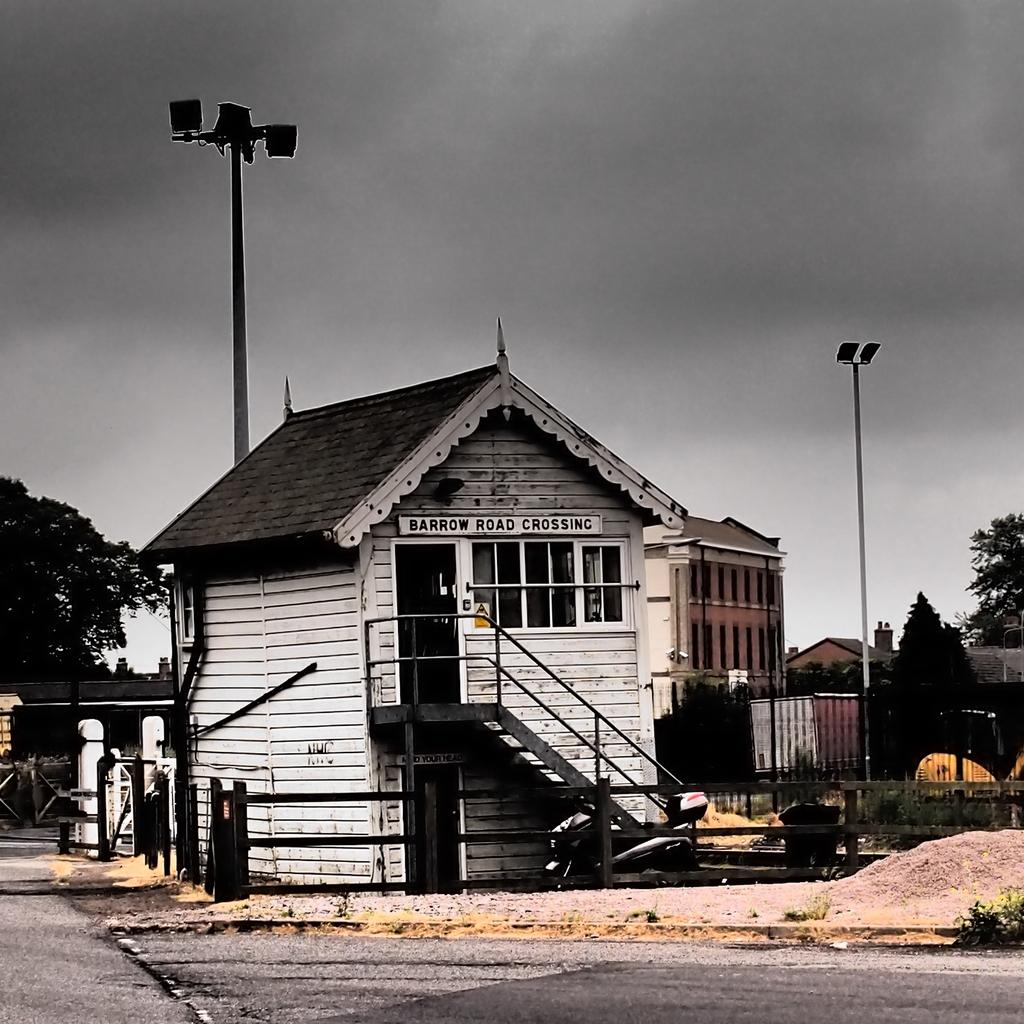What type of house is in the image? There is a wooden house in the image. What feature can be seen on the wooden house? The wooden house has glass windows. Where is the wooden house located in relation to the road? The wooden house is near a road. What can be seen in the background of the image? There are lights attached to poles, buildings, trees, and clouds visible in the sky in the background of the image. What type of organization is responsible for the nation's clouds in the image? There is no organization or nation mentioned in the image, and the clouds are a natural weather phenomenon. 